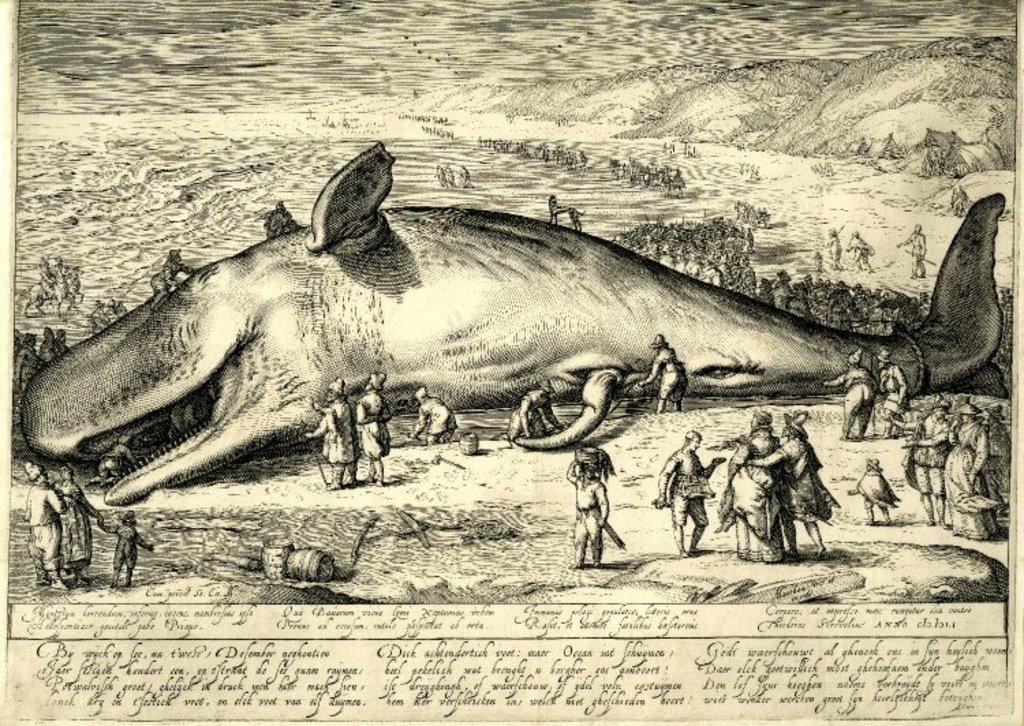Describe this image in one or two sentences. In this image I can see the fish and the group of people around and few people are holding something and I can see something is written on the paper. 